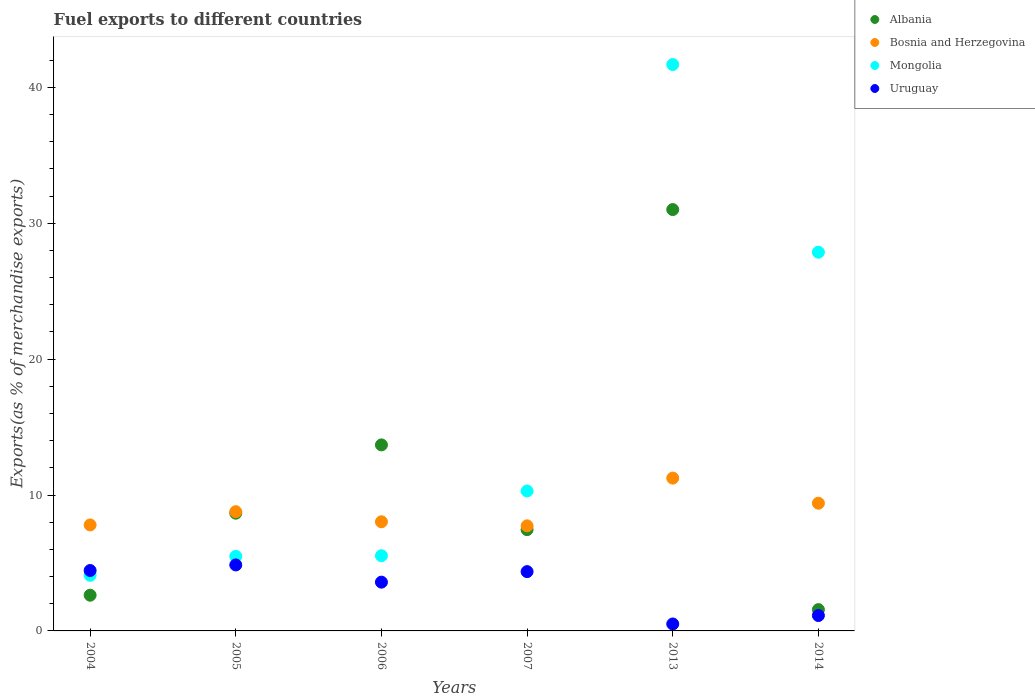How many different coloured dotlines are there?
Your answer should be very brief. 4. What is the percentage of exports to different countries in Uruguay in 2004?
Offer a very short reply. 4.44. Across all years, what is the maximum percentage of exports to different countries in Mongolia?
Offer a terse response. 41.67. Across all years, what is the minimum percentage of exports to different countries in Mongolia?
Your answer should be compact. 4.09. In which year was the percentage of exports to different countries in Uruguay maximum?
Your response must be concise. 2005. In which year was the percentage of exports to different countries in Albania minimum?
Provide a short and direct response. 2014. What is the total percentage of exports to different countries in Albania in the graph?
Your answer should be compact. 65. What is the difference between the percentage of exports to different countries in Mongolia in 2005 and that in 2007?
Offer a very short reply. -4.81. What is the difference between the percentage of exports to different countries in Mongolia in 2013 and the percentage of exports to different countries in Uruguay in 2014?
Your answer should be compact. 40.54. What is the average percentage of exports to different countries in Uruguay per year?
Give a very brief answer. 3.15. In the year 2005, what is the difference between the percentage of exports to different countries in Mongolia and percentage of exports to different countries in Bosnia and Herzegovina?
Provide a short and direct response. -3.29. In how many years, is the percentage of exports to different countries in Mongolia greater than 6 %?
Make the answer very short. 3. What is the ratio of the percentage of exports to different countries in Albania in 2004 to that in 2013?
Ensure brevity in your answer.  0.08. Is the difference between the percentage of exports to different countries in Mongolia in 2004 and 2006 greater than the difference between the percentage of exports to different countries in Bosnia and Herzegovina in 2004 and 2006?
Keep it short and to the point. No. What is the difference between the highest and the second highest percentage of exports to different countries in Albania?
Provide a short and direct response. 17.32. What is the difference between the highest and the lowest percentage of exports to different countries in Mongolia?
Provide a short and direct response. 37.58. Is it the case that in every year, the sum of the percentage of exports to different countries in Uruguay and percentage of exports to different countries in Mongolia  is greater than the sum of percentage of exports to different countries in Albania and percentage of exports to different countries in Bosnia and Herzegovina?
Your response must be concise. No. Is it the case that in every year, the sum of the percentage of exports to different countries in Mongolia and percentage of exports to different countries in Albania  is greater than the percentage of exports to different countries in Uruguay?
Provide a short and direct response. Yes. Is the percentage of exports to different countries in Mongolia strictly greater than the percentage of exports to different countries in Uruguay over the years?
Your response must be concise. No. Is the percentage of exports to different countries in Uruguay strictly less than the percentage of exports to different countries in Albania over the years?
Your answer should be compact. No. Where does the legend appear in the graph?
Provide a succinct answer. Top right. How are the legend labels stacked?
Make the answer very short. Vertical. What is the title of the graph?
Ensure brevity in your answer.  Fuel exports to different countries. What is the label or title of the Y-axis?
Your answer should be compact. Exports(as % of merchandise exports). What is the Exports(as % of merchandise exports) of Albania in 2004?
Provide a succinct answer. 2.63. What is the Exports(as % of merchandise exports) in Bosnia and Herzegovina in 2004?
Give a very brief answer. 7.8. What is the Exports(as % of merchandise exports) in Mongolia in 2004?
Give a very brief answer. 4.09. What is the Exports(as % of merchandise exports) of Uruguay in 2004?
Provide a short and direct response. 4.44. What is the Exports(as % of merchandise exports) in Albania in 2005?
Provide a short and direct response. 8.66. What is the Exports(as % of merchandise exports) in Bosnia and Herzegovina in 2005?
Ensure brevity in your answer.  8.77. What is the Exports(as % of merchandise exports) in Mongolia in 2005?
Keep it short and to the point. 5.49. What is the Exports(as % of merchandise exports) in Uruguay in 2005?
Give a very brief answer. 4.86. What is the Exports(as % of merchandise exports) in Albania in 2006?
Give a very brief answer. 13.69. What is the Exports(as % of merchandise exports) in Bosnia and Herzegovina in 2006?
Provide a succinct answer. 8.03. What is the Exports(as % of merchandise exports) in Mongolia in 2006?
Keep it short and to the point. 5.53. What is the Exports(as % of merchandise exports) in Uruguay in 2006?
Provide a succinct answer. 3.59. What is the Exports(as % of merchandise exports) of Albania in 2007?
Offer a very short reply. 7.45. What is the Exports(as % of merchandise exports) of Bosnia and Herzegovina in 2007?
Offer a terse response. 7.73. What is the Exports(as % of merchandise exports) in Mongolia in 2007?
Keep it short and to the point. 10.3. What is the Exports(as % of merchandise exports) of Uruguay in 2007?
Keep it short and to the point. 4.36. What is the Exports(as % of merchandise exports) in Albania in 2013?
Offer a terse response. 31. What is the Exports(as % of merchandise exports) of Bosnia and Herzegovina in 2013?
Offer a very short reply. 11.24. What is the Exports(as % of merchandise exports) in Mongolia in 2013?
Make the answer very short. 41.67. What is the Exports(as % of merchandise exports) in Uruguay in 2013?
Your answer should be compact. 0.51. What is the Exports(as % of merchandise exports) of Albania in 2014?
Provide a short and direct response. 1.57. What is the Exports(as % of merchandise exports) in Bosnia and Herzegovina in 2014?
Ensure brevity in your answer.  9.4. What is the Exports(as % of merchandise exports) in Mongolia in 2014?
Provide a succinct answer. 27.87. What is the Exports(as % of merchandise exports) of Uruguay in 2014?
Offer a terse response. 1.13. Across all years, what is the maximum Exports(as % of merchandise exports) in Albania?
Offer a terse response. 31. Across all years, what is the maximum Exports(as % of merchandise exports) of Bosnia and Herzegovina?
Your answer should be compact. 11.24. Across all years, what is the maximum Exports(as % of merchandise exports) in Mongolia?
Give a very brief answer. 41.67. Across all years, what is the maximum Exports(as % of merchandise exports) in Uruguay?
Keep it short and to the point. 4.86. Across all years, what is the minimum Exports(as % of merchandise exports) in Albania?
Keep it short and to the point. 1.57. Across all years, what is the minimum Exports(as % of merchandise exports) of Bosnia and Herzegovina?
Make the answer very short. 7.73. Across all years, what is the minimum Exports(as % of merchandise exports) in Mongolia?
Provide a succinct answer. 4.09. Across all years, what is the minimum Exports(as % of merchandise exports) of Uruguay?
Provide a succinct answer. 0.51. What is the total Exports(as % of merchandise exports) in Albania in the graph?
Your answer should be very brief. 65. What is the total Exports(as % of merchandise exports) of Bosnia and Herzegovina in the graph?
Make the answer very short. 52.97. What is the total Exports(as % of merchandise exports) of Mongolia in the graph?
Keep it short and to the point. 94.95. What is the total Exports(as % of merchandise exports) of Uruguay in the graph?
Provide a succinct answer. 18.9. What is the difference between the Exports(as % of merchandise exports) in Albania in 2004 and that in 2005?
Offer a terse response. -6.04. What is the difference between the Exports(as % of merchandise exports) in Bosnia and Herzegovina in 2004 and that in 2005?
Provide a succinct answer. -0.97. What is the difference between the Exports(as % of merchandise exports) of Mongolia in 2004 and that in 2005?
Make the answer very short. -1.39. What is the difference between the Exports(as % of merchandise exports) of Uruguay in 2004 and that in 2005?
Offer a terse response. -0.41. What is the difference between the Exports(as % of merchandise exports) of Albania in 2004 and that in 2006?
Your answer should be compact. -11.06. What is the difference between the Exports(as % of merchandise exports) in Bosnia and Herzegovina in 2004 and that in 2006?
Offer a very short reply. -0.23. What is the difference between the Exports(as % of merchandise exports) in Mongolia in 2004 and that in 2006?
Your answer should be very brief. -1.44. What is the difference between the Exports(as % of merchandise exports) in Uruguay in 2004 and that in 2006?
Offer a terse response. 0.86. What is the difference between the Exports(as % of merchandise exports) of Albania in 2004 and that in 2007?
Provide a short and direct response. -4.83. What is the difference between the Exports(as % of merchandise exports) in Bosnia and Herzegovina in 2004 and that in 2007?
Give a very brief answer. 0.07. What is the difference between the Exports(as % of merchandise exports) in Mongolia in 2004 and that in 2007?
Your answer should be very brief. -6.2. What is the difference between the Exports(as % of merchandise exports) of Uruguay in 2004 and that in 2007?
Ensure brevity in your answer.  0.08. What is the difference between the Exports(as % of merchandise exports) in Albania in 2004 and that in 2013?
Give a very brief answer. -28.38. What is the difference between the Exports(as % of merchandise exports) in Bosnia and Herzegovina in 2004 and that in 2013?
Offer a very short reply. -3.45. What is the difference between the Exports(as % of merchandise exports) in Mongolia in 2004 and that in 2013?
Give a very brief answer. -37.58. What is the difference between the Exports(as % of merchandise exports) in Uruguay in 2004 and that in 2013?
Offer a terse response. 3.93. What is the difference between the Exports(as % of merchandise exports) in Albania in 2004 and that in 2014?
Make the answer very short. 1.06. What is the difference between the Exports(as % of merchandise exports) in Bosnia and Herzegovina in 2004 and that in 2014?
Provide a succinct answer. -1.6. What is the difference between the Exports(as % of merchandise exports) of Mongolia in 2004 and that in 2014?
Make the answer very short. -23.77. What is the difference between the Exports(as % of merchandise exports) in Uruguay in 2004 and that in 2014?
Your answer should be very brief. 3.31. What is the difference between the Exports(as % of merchandise exports) in Albania in 2005 and that in 2006?
Provide a short and direct response. -5.02. What is the difference between the Exports(as % of merchandise exports) of Bosnia and Herzegovina in 2005 and that in 2006?
Ensure brevity in your answer.  0.74. What is the difference between the Exports(as % of merchandise exports) in Mongolia in 2005 and that in 2006?
Provide a short and direct response. -0.05. What is the difference between the Exports(as % of merchandise exports) in Uruguay in 2005 and that in 2006?
Offer a very short reply. 1.27. What is the difference between the Exports(as % of merchandise exports) of Albania in 2005 and that in 2007?
Make the answer very short. 1.21. What is the difference between the Exports(as % of merchandise exports) of Bosnia and Herzegovina in 2005 and that in 2007?
Your response must be concise. 1.04. What is the difference between the Exports(as % of merchandise exports) of Mongolia in 2005 and that in 2007?
Provide a short and direct response. -4.81. What is the difference between the Exports(as % of merchandise exports) of Uruguay in 2005 and that in 2007?
Your answer should be compact. 0.49. What is the difference between the Exports(as % of merchandise exports) of Albania in 2005 and that in 2013?
Your answer should be compact. -22.34. What is the difference between the Exports(as % of merchandise exports) of Bosnia and Herzegovina in 2005 and that in 2013?
Make the answer very short. -2.47. What is the difference between the Exports(as % of merchandise exports) of Mongolia in 2005 and that in 2013?
Give a very brief answer. -36.19. What is the difference between the Exports(as % of merchandise exports) of Uruguay in 2005 and that in 2013?
Make the answer very short. 4.34. What is the difference between the Exports(as % of merchandise exports) in Albania in 2005 and that in 2014?
Your answer should be compact. 7.1. What is the difference between the Exports(as % of merchandise exports) of Bosnia and Herzegovina in 2005 and that in 2014?
Keep it short and to the point. -0.62. What is the difference between the Exports(as % of merchandise exports) in Mongolia in 2005 and that in 2014?
Your answer should be compact. -22.38. What is the difference between the Exports(as % of merchandise exports) of Uruguay in 2005 and that in 2014?
Give a very brief answer. 3.72. What is the difference between the Exports(as % of merchandise exports) in Albania in 2006 and that in 2007?
Keep it short and to the point. 6.23. What is the difference between the Exports(as % of merchandise exports) of Bosnia and Herzegovina in 2006 and that in 2007?
Offer a terse response. 0.3. What is the difference between the Exports(as % of merchandise exports) of Mongolia in 2006 and that in 2007?
Provide a succinct answer. -4.76. What is the difference between the Exports(as % of merchandise exports) of Uruguay in 2006 and that in 2007?
Make the answer very short. -0.77. What is the difference between the Exports(as % of merchandise exports) of Albania in 2006 and that in 2013?
Give a very brief answer. -17.32. What is the difference between the Exports(as % of merchandise exports) of Bosnia and Herzegovina in 2006 and that in 2013?
Provide a short and direct response. -3.21. What is the difference between the Exports(as % of merchandise exports) in Mongolia in 2006 and that in 2013?
Make the answer very short. -36.14. What is the difference between the Exports(as % of merchandise exports) of Uruguay in 2006 and that in 2013?
Give a very brief answer. 3.08. What is the difference between the Exports(as % of merchandise exports) in Albania in 2006 and that in 2014?
Provide a short and direct response. 12.12. What is the difference between the Exports(as % of merchandise exports) in Bosnia and Herzegovina in 2006 and that in 2014?
Offer a very short reply. -1.37. What is the difference between the Exports(as % of merchandise exports) of Mongolia in 2006 and that in 2014?
Give a very brief answer. -22.33. What is the difference between the Exports(as % of merchandise exports) of Uruguay in 2006 and that in 2014?
Give a very brief answer. 2.46. What is the difference between the Exports(as % of merchandise exports) in Albania in 2007 and that in 2013?
Ensure brevity in your answer.  -23.55. What is the difference between the Exports(as % of merchandise exports) of Bosnia and Herzegovina in 2007 and that in 2013?
Offer a very short reply. -3.51. What is the difference between the Exports(as % of merchandise exports) in Mongolia in 2007 and that in 2013?
Provide a short and direct response. -31.38. What is the difference between the Exports(as % of merchandise exports) of Uruguay in 2007 and that in 2013?
Offer a terse response. 3.85. What is the difference between the Exports(as % of merchandise exports) of Albania in 2007 and that in 2014?
Make the answer very short. 5.89. What is the difference between the Exports(as % of merchandise exports) in Bosnia and Herzegovina in 2007 and that in 2014?
Your answer should be compact. -1.67. What is the difference between the Exports(as % of merchandise exports) of Mongolia in 2007 and that in 2014?
Give a very brief answer. -17.57. What is the difference between the Exports(as % of merchandise exports) of Uruguay in 2007 and that in 2014?
Provide a short and direct response. 3.23. What is the difference between the Exports(as % of merchandise exports) of Albania in 2013 and that in 2014?
Offer a very short reply. 29.44. What is the difference between the Exports(as % of merchandise exports) of Bosnia and Herzegovina in 2013 and that in 2014?
Provide a succinct answer. 1.85. What is the difference between the Exports(as % of merchandise exports) in Mongolia in 2013 and that in 2014?
Offer a terse response. 13.81. What is the difference between the Exports(as % of merchandise exports) in Uruguay in 2013 and that in 2014?
Make the answer very short. -0.62. What is the difference between the Exports(as % of merchandise exports) of Albania in 2004 and the Exports(as % of merchandise exports) of Bosnia and Herzegovina in 2005?
Your answer should be very brief. -6.14. What is the difference between the Exports(as % of merchandise exports) of Albania in 2004 and the Exports(as % of merchandise exports) of Mongolia in 2005?
Offer a very short reply. -2.86. What is the difference between the Exports(as % of merchandise exports) in Albania in 2004 and the Exports(as % of merchandise exports) in Uruguay in 2005?
Your response must be concise. -2.23. What is the difference between the Exports(as % of merchandise exports) of Bosnia and Herzegovina in 2004 and the Exports(as % of merchandise exports) of Mongolia in 2005?
Your answer should be very brief. 2.31. What is the difference between the Exports(as % of merchandise exports) of Bosnia and Herzegovina in 2004 and the Exports(as % of merchandise exports) of Uruguay in 2005?
Offer a very short reply. 2.94. What is the difference between the Exports(as % of merchandise exports) in Mongolia in 2004 and the Exports(as % of merchandise exports) in Uruguay in 2005?
Your answer should be very brief. -0.76. What is the difference between the Exports(as % of merchandise exports) of Albania in 2004 and the Exports(as % of merchandise exports) of Bosnia and Herzegovina in 2006?
Ensure brevity in your answer.  -5.4. What is the difference between the Exports(as % of merchandise exports) in Albania in 2004 and the Exports(as % of merchandise exports) in Mongolia in 2006?
Provide a succinct answer. -2.9. What is the difference between the Exports(as % of merchandise exports) of Albania in 2004 and the Exports(as % of merchandise exports) of Uruguay in 2006?
Keep it short and to the point. -0.96. What is the difference between the Exports(as % of merchandise exports) of Bosnia and Herzegovina in 2004 and the Exports(as % of merchandise exports) of Mongolia in 2006?
Your answer should be compact. 2.27. What is the difference between the Exports(as % of merchandise exports) in Bosnia and Herzegovina in 2004 and the Exports(as % of merchandise exports) in Uruguay in 2006?
Your response must be concise. 4.21. What is the difference between the Exports(as % of merchandise exports) in Mongolia in 2004 and the Exports(as % of merchandise exports) in Uruguay in 2006?
Your answer should be very brief. 0.5. What is the difference between the Exports(as % of merchandise exports) of Albania in 2004 and the Exports(as % of merchandise exports) of Bosnia and Herzegovina in 2007?
Offer a very short reply. -5.1. What is the difference between the Exports(as % of merchandise exports) in Albania in 2004 and the Exports(as % of merchandise exports) in Mongolia in 2007?
Your answer should be very brief. -7.67. What is the difference between the Exports(as % of merchandise exports) in Albania in 2004 and the Exports(as % of merchandise exports) in Uruguay in 2007?
Offer a very short reply. -1.74. What is the difference between the Exports(as % of merchandise exports) of Bosnia and Herzegovina in 2004 and the Exports(as % of merchandise exports) of Mongolia in 2007?
Make the answer very short. -2.5. What is the difference between the Exports(as % of merchandise exports) of Bosnia and Herzegovina in 2004 and the Exports(as % of merchandise exports) of Uruguay in 2007?
Give a very brief answer. 3.44. What is the difference between the Exports(as % of merchandise exports) in Mongolia in 2004 and the Exports(as % of merchandise exports) in Uruguay in 2007?
Provide a short and direct response. -0.27. What is the difference between the Exports(as % of merchandise exports) in Albania in 2004 and the Exports(as % of merchandise exports) in Bosnia and Herzegovina in 2013?
Provide a short and direct response. -8.62. What is the difference between the Exports(as % of merchandise exports) in Albania in 2004 and the Exports(as % of merchandise exports) in Mongolia in 2013?
Offer a very short reply. -39.05. What is the difference between the Exports(as % of merchandise exports) in Albania in 2004 and the Exports(as % of merchandise exports) in Uruguay in 2013?
Give a very brief answer. 2.12. What is the difference between the Exports(as % of merchandise exports) in Bosnia and Herzegovina in 2004 and the Exports(as % of merchandise exports) in Mongolia in 2013?
Provide a short and direct response. -33.87. What is the difference between the Exports(as % of merchandise exports) of Bosnia and Herzegovina in 2004 and the Exports(as % of merchandise exports) of Uruguay in 2013?
Provide a succinct answer. 7.29. What is the difference between the Exports(as % of merchandise exports) in Mongolia in 2004 and the Exports(as % of merchandise exports) in Uruguay in 2013?
Offer a terse response. 3.58. What is the difference between the Exports(as % of merchandise exports) of Albania in 2004 and the Exports(as % of merchandise exports) of Bosnia and Herzegovina in 2014?
Offer a terse response. -6.77. What is the difference between the Exports(as % of merchandise exports) of Albania in 2004 and the Exports(as % of merchandise exports) of Mongolia in 2014?
Offer a very short reply. -25.24. What is the difference between the Exports(as % of merchandise exports) in Albania in 2004 and the Exports(as % of merchandise exports) in Uruguay in 2014?
Give a very brief answer. 1.49. What is the difference between the Exports(as % of merchandise exports) in Bosnia and Herzegovina in 2004 and the Exports(as % of merchandise exports) in Mongolia in 2014?
Provide a succinct answer. -20.07. What is the difference between the Exports(as % of merchandise exports) of Bosnia and Herzegovina in 2004 and the Exports(as % of merchandise exports) of Uruguay in 2014?
Make the answer very short. 6.67. What is the difference between the Exports(as % of merchandise exports) in Mongolia in 2004 and the Exports(as % of merchandise exports) in Uruguay in 2014?
Keep it short and to the point. 2.96. What is the difference between the Exports(as % of merchandise exports) in Albania in 2005 and the Exports(as % of merchandise exports) in Bosnia and Herzegovina in 2006?
Your answer should be compact. 0.63. What is the difference between the Exports(as % of merchandise exports) of Albania in 2005 and the Exports(as % of merchandise exports) of Mongolia in 2006?
Offer a very short reply. 3.13. What is the difference between the Exports(as % of merchandise exports) of Albania in 2005 and the Exports(as % of merchandise exports) of Uruguay in 2006?
Keep it short and to the point. 5.07. What is the difference between the Exports(as % of merchandise exports) of Bosnia and Herzegovina in 2005 and the Exports(as % of merchandise exports) of Mongolia in 2006?
Offer a terse response. 3.24. What is the difference between the Exports(as % of merchandise exports) of Bosnia and Herzegovina in 2005 and the Exports(as % of merchandise exports) of Uruguay in 2006?
Give a very brief answer. 5.18. What is the difference between the Exports(as % of merchandise exports) of Mongolia in 2005 and the Exports(as % of merchandise exports) of Uruguay in 2006?
Provide a succinct answer. 1.9. What is the difference between the Exports(as % of merchandise exports) of Albania in 2005 and the Exports(as % of merchandise exports) of Bosnia and Herzegovina in 2007?
Provide a succinct answer. 0.93. What is the difference between the Exports(as % of merchandise exports) in Albania in 2005 and the Exports(as % of merchandise exports) in Mongolia in 2007?
Your response must be concise. -1.63. What is the difference between the Exports(as % of merchandise exports) of Albania in 2005 and the Exports(as % of merchandise exports) of Uruguay in 2007?
Give a very brief answer. 4.3. What is the difference between the Exports(as % of merchandise exports) in Bosnia and Herzegovina in 2005 and the Exports(as % of merchandise exports) in Mongolia in 2007?
Keep it short and to the point. -1.52. What is the difference between the Exports(as % of merchandise exports) of Bosnia and Herzegovina in 2005 and the Exports(as % of merchandise exports) of Uruguay in 2007?
Provide a short and direct response. 4.41. What is the difference between the Exports(as % of merchandise exports) in Mongolia in 2005 and the Exports(as % of merchandise exports) in Uruguay in 2007?
Give a very brief answer. 1.12. What is the difference between the Exports(as % of merchandise exports) of Albania in 2005 and the Exports(as % of merchandise exports) of Bosnia and Herzegovina in 2013?
Your answer should be very brief. -2.58. What is the difference between the Exports(as % of merchandise exports) in Albania in 2005 and the Exports(as % of merchandise exports) in Mongolia in 2013?
Your answer should be compact. -33.01. What is the difference between the Exports(as % of merchandise exports) of Albania in 2005 and the Exports(as % of merchandise exports) of Uruguay in 2013?
Make the answer very short. 8.15. What is the difference between the Exports(as % of merchandise exports) in Bosnia and Herzegovina in 2005 and the Exports(as % of merchandise exports) in Mongolia in 2013?
Provide a succinct answer. -32.9. What is the difference between the Exports(as % of merchandise exports) of Bosnia and Herzegovina in 2005 and the Exports(as % of merchandise exports) of Uruguay in 2013?
Make the answer very short. 8.26. What is the difference between the Exports(as % of merchandise exports) of Mongolia in 2005 and the Exports(as % of merchandise exports) of Uruguay in 2013?
Provide a short and direct response. 4.98. What is the difference between the Exports(as % of merchandise exports) of Albania in 2005 and the Exports(as % of merchandise exports) of Bosnia and Herzegovina in 2014?
Your response must be concise. -0.73. What is the difference between the Exports(as % of merchandise exports) in Albania in 2005 and the Exports(as % of merchandise exports) in Mongolia in 2014?
Offer a terse response. -19.2. What is the difference between the Exports(as % of merchandise exports) in Albania in 2005 and the Exports(as % of merchandise exports) in Uruguay in 2014?
Provide a succinct answer. 7.53. What is the difference between the Exports(as % of merchandise exports) of Bosnia and Herzegovina in 2005 and the Exports(as % of merchandise exports) of Mongolia in 2014?
Give a very brief answer. -19.09. What is the difference between the Exports(as % of merchandise exports) of Bosnia and Herzegovina in 2005 and the Exports(as % of merchandise exports) of Uruguay in 2014?
Ensure brevity in your answer.  7.64. What is the difference between the Exports(as % of merchandise exports) in Mongolia in 2005 and the Exports(as % of merchandise exports) in Uruguay in 2014?
Provide a succinct answer. 4.35. What is the difference between the Exports(as % of merchandise exports) of Albania in 2006 and the Exports(as % of merchandise exports) of Bosnia and Herzegovina in 2007?
Your response must be concise. 5.96. What is the difference between the Exports(as % of merchandise exports) of Albania in 2006 and the Exports(as % of merchandise exports) of Mongolia in 2007?
Offer a terse response. 3.39. What is the difference between the Exports(as % of merchandise exports) in Albania in 2006 and the Exports(as % of merchandise exports) in Uruguay in 2007?
Your response must be concise. 9.32. What is the difference between the Exports(as % of merchandise exports) of Bosnia and Herzegovina in 2006 and the Exports(as % of merchandise exports) of Mongolia in 2007?
Your answer should be compact. -2.27. What is the difference between the Exports(as % of merchandise exports) of Bosnia and Herzegovina in 2006 and the Exports(as % of merchandise exports) of Uruguay in 2007?
Your answer should be very brief. 3.67. What is the difference between the Exports(as % of merchandise exports) in Mongolia in 2006 and the Exports(as % of merchandise exports) in Uruguay in 2007?
Your answer should be very brief. 1.17. What is the difference between the Exports(as % of merchandise exports) in Albania in 2006 and the Exports(as % of merchandise exports) in Bosnia and Herzegovina in 2013?
Make the answer very short. 2.44. What is the difference between the Exports(as % of merchandise exports) of Albania in 2006 and the Exports(as % of merchandise exports) of Mongolia in 2013?
Your response must be concise. -27.99. What is the difference between the Exports(as % of merchandise exports) in Albania in 2006 and the Exports(as % of merchandise exports) in Uruguay in 2013?
Offer a very short reply. 13.18. What is the difference between the Exports(as % of merchandise exports) of Bosnia and Herzegovina in 2006 and the Exports(as % of merchandise exports) of Mongolia in 2013?
Offer a terse response. -33.64. What is the difference between the Exports(as % of merchandise exports) of Bosnia and Herzegovina in 2006 and the Exports(as % of merchandise exports) of Uruguay in 2013?
Keep it short and to the point. 7.52. What is the difference between the Exports(as % of merchandise exports) in Mongolia in 2006 and the Exports(as % of merchandise exports) in Uruguay in 2013?
Your response must be concise. 5.02. What is the difference between the Exports(as % of merchandise exports) in Albania in 2006 and the Exports(as % of merchandise exports) in Bosnia and Herzegovina in 2014?
Make the answer very short. 4.29. What is the difference between the Exports(as % of merchandise exports) of Albania in 2006 and the Exports(as % of merchandise exports) of Mongolia in 2014?
Your answer should be compact. -14.18. What is the difference between the Exports(as % of merchandise exports) in Albania in 2006 and the Exports(as % of merchandise exports) in Uruguay in 2014?
Provide a short and direct response. 12.55. What is the difference between the Exports(as % of merchandise exports) in Bosnia and Herzegovina in 2006 and the Exports(as % of merchandise exports) in Mongolia in 2014?
Make the answer very short. -19.83. What is the difference between the Exports(as % of merchandise exports) of Bosnia and Herzegovina in 2006 and the Exports(as % of merchandise exports) of Uruguay in 2014?
Keep it short and to the point. 6.9. What is the difference between the Exports(as % of merchandise exports) of Mongolia in 2006 and the Exports(as % of merchandise exports) of Uruguay in 2014?
Give a very brief answer. 4.4. What is the difference between the Exports(as % of merchandise exports) in Albania in 2007 and the Exports(as % of merchandise exports) in Bosnia and Herzegovina in 2013?
Give a very brief answer. -3.79. What is the difference between the Exports(as % of merchandise exports) of Albania in 2007 and the Exports(as % of merchandise exports) of Mongolia in 2013?
Your answer should be compact. -34.22. What is the difference between the Exports(as % of merchandise exports) of Albania in 2007 and the Exports(as % of merchandise exports) of Uruguay in 2013?
Keep it short and to the point. 6.94. What is the difference between the Exports(as % of merchandise exports) in Bosnia and Herzegovina in 2007 and the Exports(as % of merchandise exports) in Mongolia in 2013?
Keep it short and to the point. -33.94. What is the difference between the Exports(as % of merchandise exports) of Bosnia and Herzegovina in 2007 and the Exports(as % of merchandise exports) of Uruguay in 2013?
Give a very brief answer. 7.22. What is the difference between the Exports(as % of merchandise exports) in Mongolia in 2007 and the Exports(as % of merchandise exports) in Uruguay in 2013?
Provide a succinct answer. 9.79. What is the difference between the Exports(as % of merchandise exports) of Albania in 2007 and the Exports(as % of merchandise exports) of Bosnia and Herzegovina in 2014?
Your answer should be very brief. -1.94. What is the difference between the Exports(as % of merchandise exports) in Albania in 2007 and the Exports(as % of merchandise exports) in Mongolia in 2014?
Provide a short and direct response. -20.41. What is the difference between the Exports(as % of merchandise exports) of Albania in 2007 and the Exports(as % of merchandise exports) of Uruguay in 2014?
Keep it short and to the point. 6.32. What is the difference between the Exports(as % of merchandise exports) in Bosnia and Herzegovina in 2007 and the Exports(as % of merchandise exports) in Mongolia in 2014?
Offer a terse response. -20.13. What is the difference between the Exports(as % of merchandise exports) of Bosnia and Herzegovina in 2007 and the Exports(as % of merchandise exports) of Uruguay in 2014?
Your answer should be very brief. 6.6. What is the difference between the Exports(as % of merchandise exports) in Mongolia in 2007 and the Exports(as % of merchandise exports) in Uruguay in 2014?
Your answer should be very brief. 9.16. What is the difference between the Exports(as % of merchandise exports) in Albania in 2013 and the Exports(as % of merchandise exports) in Bosnia and Herzegovina in 2014?
Your answer should be very brief. 21.61. What is the difference between the Exports(as % of merchandise exports) of Albania in 2013 and the Exports(as % of merchandise exports) of Mongolia in 2014?
Ensure brevity in your answer.  3.14. What is the difference between the Exports(as % of merchandise exports) in Albania in 2013 and the Exports(as % of merchandise exports) in Uruguay in 2014?
Your answer should be compact. 29.87. What is the difference between the Exports(as % of merchandise exports) of Bosnia and Herzegovina in 2013 and the Exports(as % of merchandise exports) of Mongolia in 2014?
Your response must be concise. -16.62. What is the difference between the Exports(as % of merchandise exports) of Bosnia and Herzegovina in 2013 and the Exports(as % of merchandise exports) of Uruguay in 2014?
Offer a very short reply. 10.11. What is the difference between the Exports(as % of merchandise exports) in Mongolia in 2013 and the Exports(as % of merchandise exports) in Uruguay in 2014?
Offer a very short reply. 40.54. What is the average Exports(as % of merchandise exports) of Albania per year?
Provide a short and direct response. 10.83. What is the average Exports(as % of merchandise exports) of Bosnia and Herzegovina per year?
Keep it short and to the point. 8.83. What is the average Exports(as % of merchandise exports) in Mongolia per year?
Ensure brevity in your answer.  15.82. What is the average Exports(as % of merchandise exports) in Uruguay per year?
Offer a very short reply. 3.15. In the year 2004, what is the difference between the Exports(as % of merchandise exports) in Albania and Exports(as % of merchandise exports) in Bosnia and Herzegovina?
Your answer should be compact. -5.17. In the year 2004, what is the difference between the Exports(as % of merchandise exports) of Albania and Exports(as % of merchandise exports) of Mongolia?
Offer a terse response. -1.46. In the year 2004, what is the difference between the Exports(as % of merchandise exports) of Albania and Exports(as % of merchandise exports) of Uruguay?
Offer a very short reply. -1.82. In the year 2004, what is the difference between the Exports(as % of merchandise exports) of Bosnia and Herzegovina and Exports(as % of merchandise exports) of Mongolia?
Offer a very short reply. 3.71. In the year 2004, what is the difference between the Exports(as % of merchandise exports) of Bosnia and Herzegovina and Exports(as % of merchandise exports) of Uruguay?
Your response must be concise. 3.35. In the year 2004, what is the difference between the Exports(as % of merchandise exports) in Mongolia and Exports(as % of merchandise exports) in Uruguay?
Ensure brevity in your answer.  -0.35. In the year 2005, what is the difference between the Exports(as % of merchandise exports) in Albania and Exports(as % of merchandise exports) in Bosnia and Herzegovina?
Provide a short and direct response. -0.11. In the year 2005, what is the difference between the Exports(as % of merchandise exports) of Albania and Exports(as % of merchandise exports) of Mongolia?
Your answer should be compact. 3.18. In the year 2005, what is the difference between the Exports(as % of merchandise exports) of Albania and Exports(as % of merchandise exports) of Uruguay?
Offer a terse response. 3.81. In the year 2005, what is the difference between the Exports(as % of merchandise exports) in Bosnia and Herzegovina and Exports(as % of merchandise exports) in Mongolia?
Provide a succinct answer. 3.29. In the year 2005, what is the difference between the Exports(as % of merchandise exports) in Bosnia and Herzegovina and Exports(as % of merchandise exports) in Uruguay?
Provide a succinct answer. 3.92. In the year 2005, what is the difference between the Exports(as % of merchandise exports) in Mongolia and Exports(as % of merchandise exports) in Uruguay?
Give a very brief answer. 0.63. In the year 2006, what is the difference between the Exports(as % of merchandise exports) of Albania and Exports(as % of merchandise exports) of Bosnia and Herzegovina?
Your answer should be very brief. 5.66. In the year 2006, what is the difference between the Exports(as % of merchandise exports) in Albania and Exports(as % of merchandise exports) in Mongolia?
Give a very brief answer. 8.15. In the year 2006, what is the difference between the Exports(as % of merchandise exports) in Albania and Exports(as % of merchandise exports) in Uruguay?
Provide a succinct answer. 10.1. In the year 2006, what is the difference between the Exports(as % of merchandise exports) in Bosnia and Herzegovina and Exports(as % of merchandise exports) in Mongolia?
Offer a very short reply. 2.5. In the year 2006, what is the difference between the Exports(as % of merchandise exports) in Bosnia and Herzegovina and Exports(as % of merchandise exports) in Uruguay?
Offer a terse response. 4.44. In the year 2006, what is the difference between the Exports(as % of merchandise exports) in Mongolia and Exports(as % of merchandise exports) in Uruguay?
Offer a terse response. 1.94. In the year 2007, what is the difference between the Exports(as % of merchandise exports) of Albania and Exports(as % of merchandise exports) of Bosnia and Herzegovina?
Ensure brevity in your answer.  -0.28. In the year 2007, what is the difference between the Exports(as % of merchandise exports) in Albania and Exports(as % of merchandise exports) in Mongolia?
Your answer should be compact. -2.84. In the year 2007, what is the difference between the Exports(as % of merchandise exports) in Albania and Exports(as % of merchandise exports) in Uruguay?
Offer a terse response. 3.09. In the year 2007, what is the difference between the Exports(as % of merchandise exports) of Bosnia and Herzegovina and Exports(as % of merchandise exports) of Mongolia?
Make the answer very short. -2.57. In the year 2007, what is the difference between the Exports(as % of merchandise exports) of Bosnia and Herzegovina and Exports(as % of merchandise exports) of Uruguay?
Your answer should be compact. 3.37. In the year 2007, what is the difference between the Exports(as % of merchandise exports) of Mongolia and Exports(as % of merchandise exports) of Uruguay?
Offer a very short reply. 5.93. In the year 2013, what is the difference between the Exports(as % of merchandise exports) in Albania and Exports(as % of merchandise exports) in Bosnia and Herzegovina?
Make the answer very short. 19.76. In the year 2013, what is the difference between the Exports(as % of merchandise exports) of Albania and Exports(as % of merchandise exports) of Mongolia?
Your answer should be very brief. -10.67. In the year 2013, what is the difference between the Exports(as % of merchandise exports) of Albania and Exports(as % of merchandise exports) of Uruguay?
Ensure brevity in your answer.  30.49. In the year 2013, what is the difference between the Exports(as % of merchandise exports) in Bosnia and Herzegovina and Exports(as % of merchandise exports) in Mongolia?
Ensure brevity in your answer.  -30.43. In the year 2013, what is the difference between the Exports(as % of merchandise exports) in Bosnia and Herzegovina and Exports(as % of merchandise exports) in Uruguay?
Keep it short and to the point. 10.73. In the year 2013, what is the difference between the Exports(as % of merchandise exports) of Mongolia and Exports(as % of merchandise exports) of Uruguay?
Your answer should be compact. 41.16. In the year 2014, what is the difference between the Exports(as % of merchandise exports) in Albania and Exports(as % of merchandise exports) in Bosnia and Herzegovina?
Provide a short and direct response. -7.83. In the year 2014, what is the difference between the Exports(as % of merchandise exports) in Albania and Exports(as % of merchandise exports) in Mongolia?
Keep it short and to the point. -26.3. In the year 2014, what is the difference between the Exports(as % of merchandise exports) in Albania and Exports(as % of merchandise exports) in Uruguay?
Make the answer very short. 0.43. In the year 2014, what is the difference between the Exports(as % of merchandise exports) in Bosnia and Herzegovina and Exports(as % of merchandise exports) in Mongolia?
Ensure brevity in your answer.  -18.47. In the year 2014, what is the difference between the Exports(as % of merchandise exports) in Bosnia and Herzegovina and Exports(as % of merchandise exports) in Uruguay?
Make the answer very short. 8.26. In the year 2014, what is the difference between the Exports(as % of merchandise exports) in Mongolia and Exports(as % of merchandise exports) in Uruguay?
Provide a succinct answer. 26.73. What is the ratio of the Exports(as % of merchandise exports) of Albania in 2004 to that in 2005?
Keep it short and to the point. 0.3. What is the ratio of the Exports(as % of merchandise exports) of Bosnia and Herzegovina in 2004 to that in 2005?
Your response must be concise. 0.89. What is the ratio of the Exports(as % of merchandise exports) in Mongolia in 2004 to that in 2005?
Provide a short and direct response. 0.75. What is the ratio of the Exports(as % of merchandise exports) in Uruguay in 2004 to that in 2005?
Give a very brief answer. 0.92. What is the ratio of the Exports(as % of merchandise exports) in Albania in 2004 to that in 2006?
Provide a succinct answer. 0.19. What is the ratio of the Exports(as % of merchandise exports) of Bosnia and Herzegovina in 2004 to that in 2006?
Your response must be concise. 0.97. What is the ratio of the Exports(as % of merchandise exports) of Mongolia in 2004 to that in 2006?
Offer a very short reply. 0.74. What is the ratio of the Exports(as % of merchandise exports) of Uruguay in 2004 to that in 2006?
Offer a terse response. 1.24. What is the ratio of the Exports(as % of merchandise exports) in Albania in 2004 to that in 2007?
Your response must be concise. 0.35. What is the ratio of the Exports(as % of merchandise exports) of Bosnia and Herzegovina in 2004 to that in 2007?
Make the answer very short. 1.01. What is the ratio of the Exports(as % of merchandise exports) in Mongolia in 2004 to that in 2007?
Your answer should be very brief. 0.4. What is the ratio of the Exports(as % of merchandise exports) of Uruguay in 2004 to that in 2007?
Provide a short and direct response. 1.02. What is the ratio of the Exports(as % of merchandise exports) in Albania in 2004 to that in 2013?
Provide a succinct answer. 0.08. What is the ratio of the Exports(as % of merchandise exports) in Bosnia and Herzegovina in 2004 to that in 2013?
Keep it short and to the point. 0.69. What is the ratio of the Exports(as % of merchandise exports) in Mongolia in 2004 to that in 2013?
Ensure brevity in your answer.  0.1. What is the ratio of the Exports(as % of merchandise exports) in Uruguay in 2004 to that in 2013?
Offer a terse response. 8.7. What is the ratio of the Exports(as % of merchandise exports) of Albania in 2004 to that in 2014?
Offer a very short reply. 1.68. What is the ratio of the Exports(as % of merchandise exports) in Bosnia and Herzegovina in 2004 to that in 2014?
Your answer should be very brief. 0.83. What is the ratio of the Exports(as % of merchandise exports) in Mongolia in 2004 to that in 2014?
Your answer should be very brief. 0.15. What is the ratio of the Exports(as % of merchandise exports) in Uruguay in 2004 to that in 2014?
Ensure brevity in your answer.  3.92. What is the ratio of the Exports(as % of merchandise exports) of Albania in 2005 to that in 2006?
Give a very brief answer. 0.63. What is the ratio of the Exports(as % of merchandise exports) of Bosnia and Herzegovina in 2005 to that in 2006?
Provide a succinct answer. 1.09. What is the ratio of the Exports(as % of merchandise exports) of Uruguay in 2005 to that in 2006?
Offer a terse response. 1.35. What is the ratio of the Exports(as % of merchandise exports) in Albania in 2005 to that in 2007?
Give a very brief answer. 1.16. What is the ratio of the Exports(as % of merchandise exports) in Bosnia and Herzegovina in 2005 to that in 2007?
Offer a very short reply. 1.13. What is the ratio of the Exports(as % of merchandise exports) in Mongolia in 2005 to that in 2007?
Offer a terse response. 0.53. What is the ratio of the Exports(as % of merchandise exports) in Uruguay in 2005 to that in 2007?
Ensure brevity in your answer.  1.11. What is the ratio of the Exports(as % of merchandise exports) of Albania in 2005 to that in 2013?
Provide a short and direct response. 0.28. What is the ratio of the Exports(as % of merchandise exports) of Bosnia and Herzegovina in 2005 to that in 2013?
Make the answer very short. 0.78. What is the ratio of the Exports(as % of merchandise exports) of Mongolia in 2005 to that in 2013?
Your response must be concise. 0.13. What is the ratio of the Exports(as % of merchandise exports) of Uruguay in 2005 to that in 2013?
Your answer should be very brief. 9.5. What is the ratio of the Exports(as % of merchandise exports) of Albania in 2005 to that in 2014?
Give a very brief answer. 5.53. What is the ratio of the Exports(as % of merchandise exports) in Bosnia and Herzegovina in 2005 to that in 2014?
Offer a terse response. 0.93. What is the ratio of the Exports(as % of merchandise exports) in Mongolia in 2005 to that in 2014?
Give a very brief answer. 0.2. What is the ratio of the Exports(as % of merchandise exports) in Uruguay in 2005 to that in 2014?
Keep it short and to the point. 4.28. What is the ratio of the Exports(as % of merchandise exports) of Albania in 2006 to that in 2007?
Your answer should be very brief. 1.84. What is the ratio of the Exports(as % of merchandise exports) in Bosnia and Herzegovina in 2006 to that in 2007?
Provide a short and direct response. 1.04. What is the ratio of the Exports(as % of merchandise exports) of Mongolia in 2006 to that in 2007?
Provide a succinct answer. 0.54. What is the ratio of the Exports(as % of merchandise exports) in Uruguay in 2006 to that in 2007?
Your response must be concise. 0.82. What is the ratio of the Exports(as % of merchandise exports) in Albania in 2006 to that in 2013?
Your response must be concise. 0.44. What is the ratio of the Exports(as % of merchandise exports) in Bosnia and Herzegovina in 2006 to that in 2013?
Your response must be concise. 0.71. What is the ratio of the Exports(as % of merchandise exports) in Mongolia in 2006 to that in 2013?
Ensure brevity in your answer.  0.13. What is the ratio of the Exports(as % of merchandise exports) of Uruguay in 2006 to that in 2013?
Keep it short and to the point. 7.02. What is the ratio of the Exports(as % of merchandise exports) in Albania in 2006 to that in 2014?
Keep it short and to the point. 8.73. What is the ratio of the Exports(as % of merchandise exports) in Bosnia and Herzegovina in 2006 to that in 2014?
Offer a terse response. 0.85. What is the ratio of the Exports(as % of merchandise exports) in Mongolia in 2006 to that in 2014?
Your response must be concise. 0.2. What is the ratio of the Exports(as % of merchandise exports) of Uruguay in 2006 to that in 2014?
Ensure brevity in your answer.  3.17. What is the ratio of the Exports(as % of merchandise exports) of Albania in 2007 to that in 2013?
Offer a very short reply. 0.24. What is the ratio of the Exports(as % of merchandise exports) in Bosnia and Herzegovina in 2007 to that in 2013?
Offer a very short reply. 0.69. What is the ratio of the Exports(as % of merchandise exports) in Mongolia in 2007 to that in 2013?
Provide a short and direct response. 0.25. What is the ratio of the Exports(as % of merchandise exports) in Uruguay in 2007 to that in 2013?
Keep it short and to the point. 8.54. What is the ratio of the Exports(as % of merchandise exports) of Albania in 2007 to that in 2014?
Give a very brief answer. 4.75. What is the ratio of the Exports(as % of merchandise exports) in Bosnia and Herzegovina in 2007 to that in 2014?
Provide a short and direct response. 0.82. What is the ratio of the Exports(as % of merchandise exports) in Mongolia in 2007 to that in 2014?
Provide a short and direct response. 0.37. What is the ratio of the Exports(as % of merchandise exports) in Uruguay in 2007 to that in 2014?
Ensure brevity in your answer.  3.85. What is the ratio of the Exports(as % of merchandise exports) of Albania in 2013 to that in 2014?
Offer a terse response. 19.78. What is the ratio of the Exports(as % of merchandise exports) of Bosnia and Herzegovina in 2013 to that in 2014?
Provide a succinct answer. 1.2. What is the ratio of the Exports(as % of merchandise exports) of Mongolia in 2013 to that in 2014?
Keep it short and to the point. 1.5. What is the ratio of the Exports(as % of merchandise exports) in Uruguay in 2013 to that in 2014?
Offer a very short reply. 0.45. What is the difference between the highest and the second highest Exports(as % of merchandise exports) of Albania?
Provide a succinct answer. 17.32. What is the difference between the highest and the second highest Exports(as % of merchandise exports) of Bosnia and Herzegovina?
Provide a succinct answer. 1.85. What is the difference between the highest and the second highest Exports(as % of merchandise exports) of Mongolia?
Keep it short and to the point. 13.81. What is the difference between the highest and the second highest Exports(as % of merchandise exports) of Uruguay?
Your answer should be compact. 0.41. What is the difference between the highest and the lowest Exports(as % of merchandise exports) in Albania?
Keep it short and to the point. 29.44. What is the difference between the highest and the lowest Exports(as % of merchandise exports) of Bosnia and Herzegovina?
Your response must be concise. 3.51. What is the difference between the highest and the lowest Exports(as % of merchandise exports) of Mongolia?
Provide a short and direct response. 37.58. What is the difference between the highest and the lowest Exports(as % of merchandise exports) of Uruguay?
Provide a short and direct response. 4.34. 